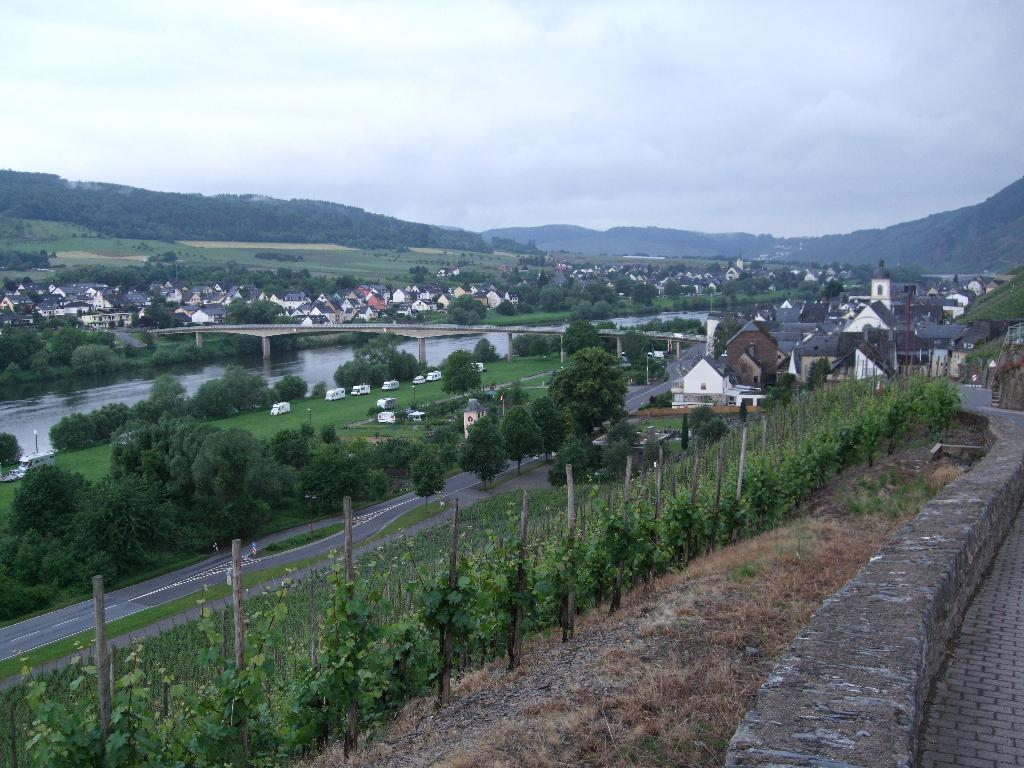Could you give a brief overview of what you see in this image? This is the picture of a city. In this image there are buildings and trees and there is a bridge and there are vehicles. At the back there are mountains. At the top there is sky and there are clouds. At the bottom there is water and there is grass and there is a road. In the foreground there is a fence and there are plants. On the right side of the image there is a road. 